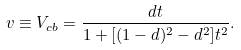Convert formula to latex. <formula><loc_0><loc_0><loc_500><loc_500>v \equiv V _ { c b } = \frac { d t } { 1 + [ ( 1 - d ) ^ { 2 } - d ^ { 2 } ] t ^ { 2 } } .</formula> 